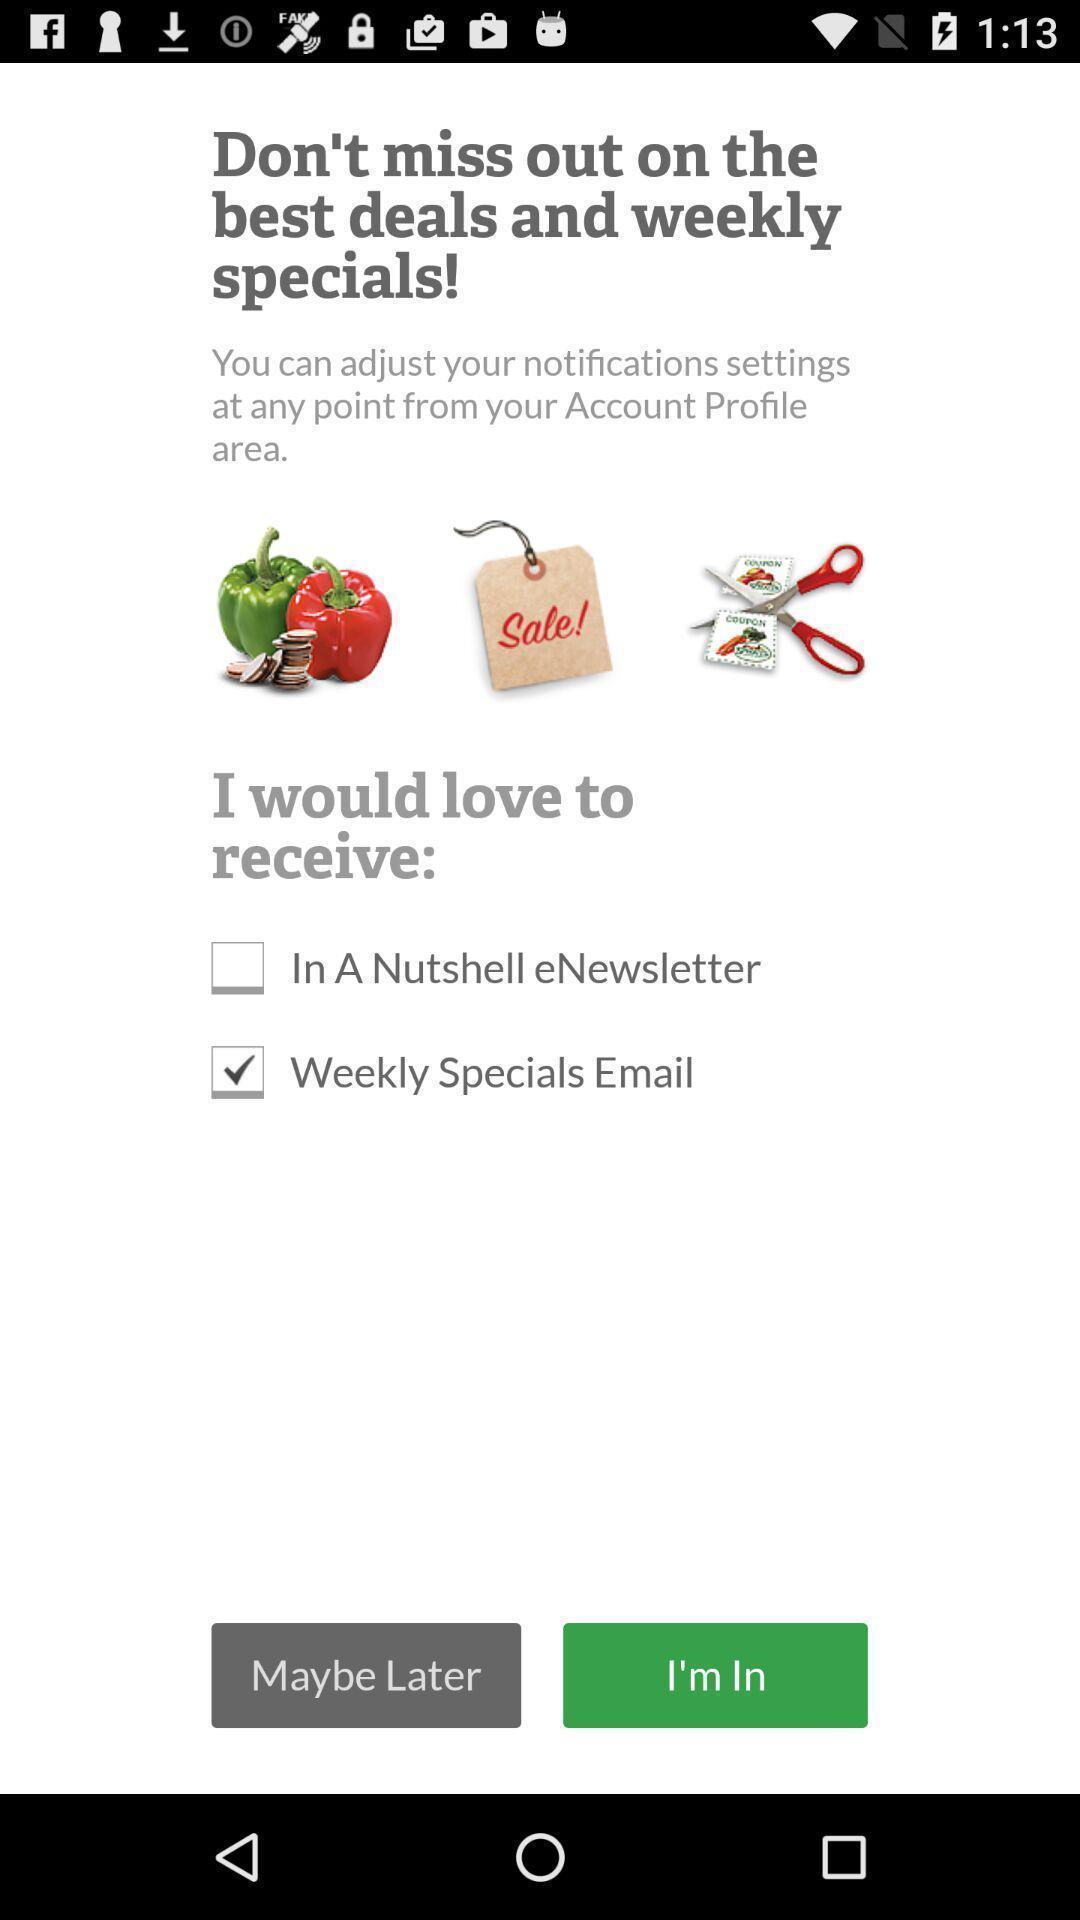Summarize the information in this screenshot. Starting page. 